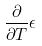Convert formula to latex. <formula><loc_0><loc_0><loc_500><loc_500>\frac { \partial } { \partial T } \epsilon</formula> 